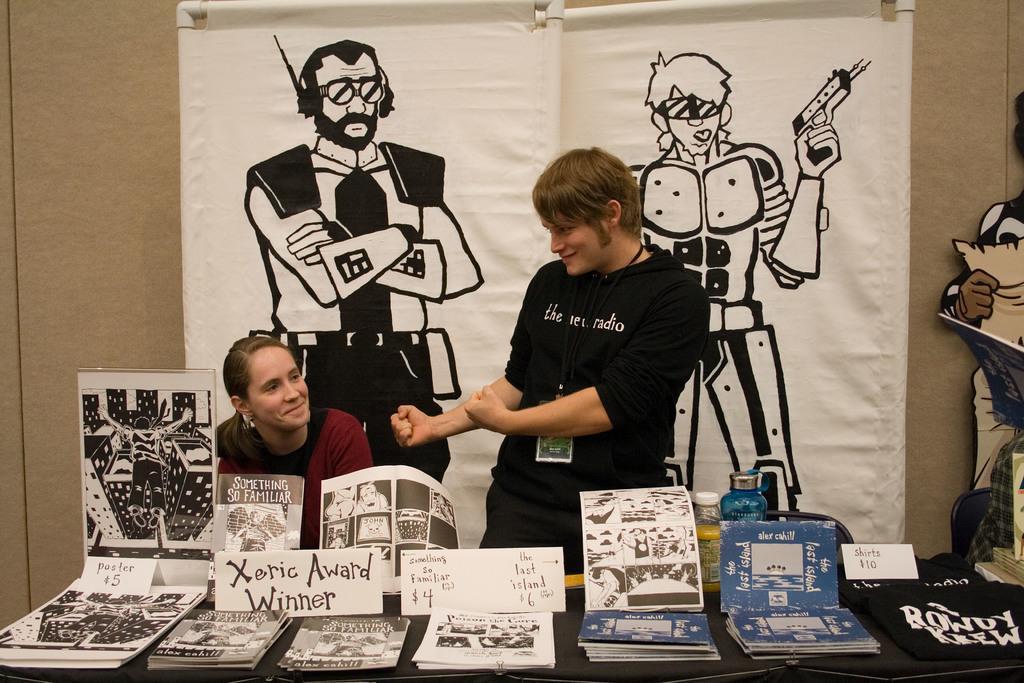Could you give a brief overview of what you see in this image? In this image I can see 2 persons and I can see smile on their faces. Here I can see number of papers, few books, cloths, few boards and I can see something is written at few places. I can also see few bottles and in the background I can see few posters. 